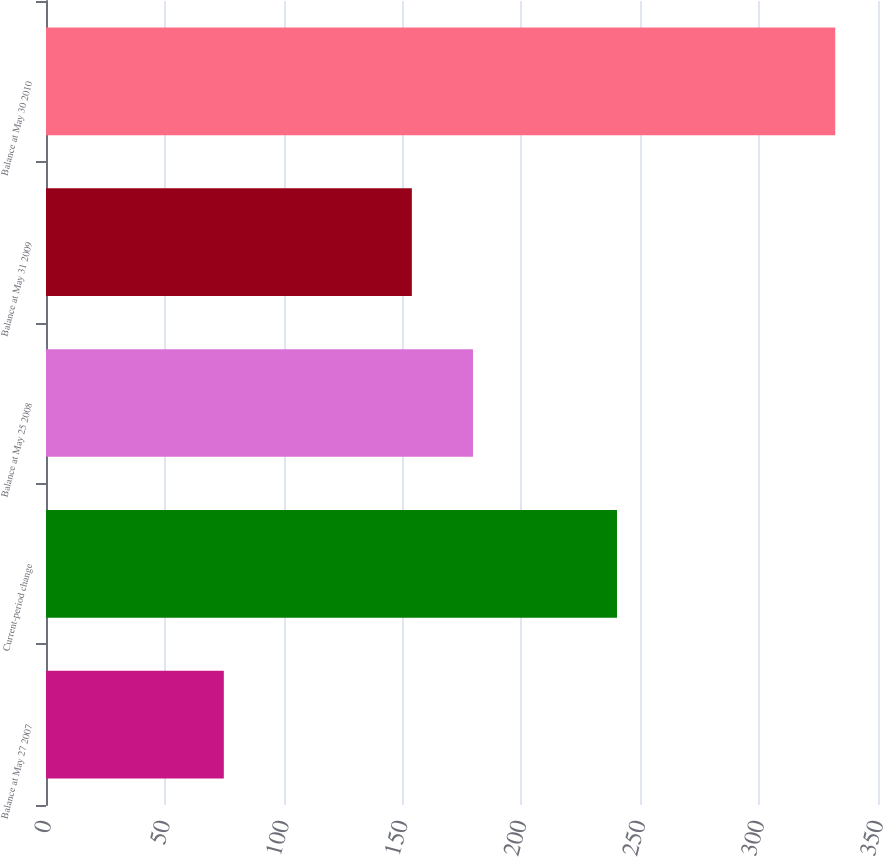<chart> <loc_0><loc_0><loc_500><loc_500><bar_chart><fcel>Balance at May 27 2007<fcel>Current-period change<fcel>Balance at May 25 2008<fcel>Balance at May 31 2009<fcel>Balance at May 30 2010<nl><fcel>74.8<fcel>240.2<fcel>179.62<fcel>153.9<fcel>332<nl></chart> 